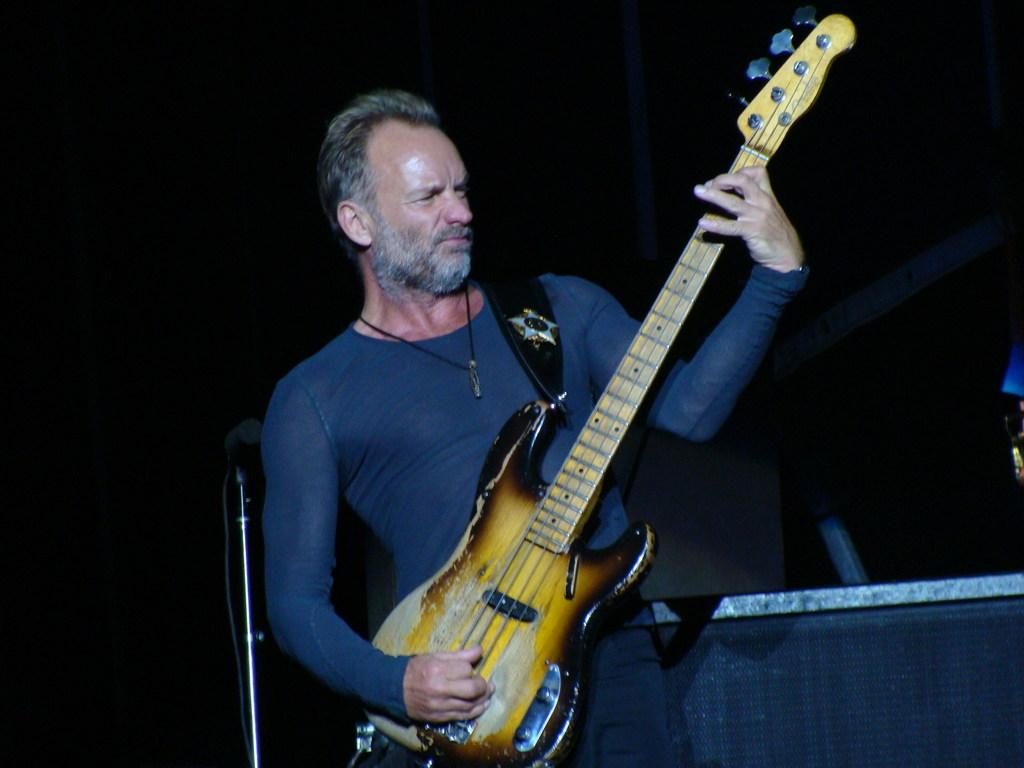Who is the main subject in the image? There is a man in the image. What is the man doing in the image? The man is standing and playing a guitar. What color is the stove in the image? There is no stove present in the image. How many legs does the man have in the image? The man has two legs in the image, but we do not need to count them to answer this question. 